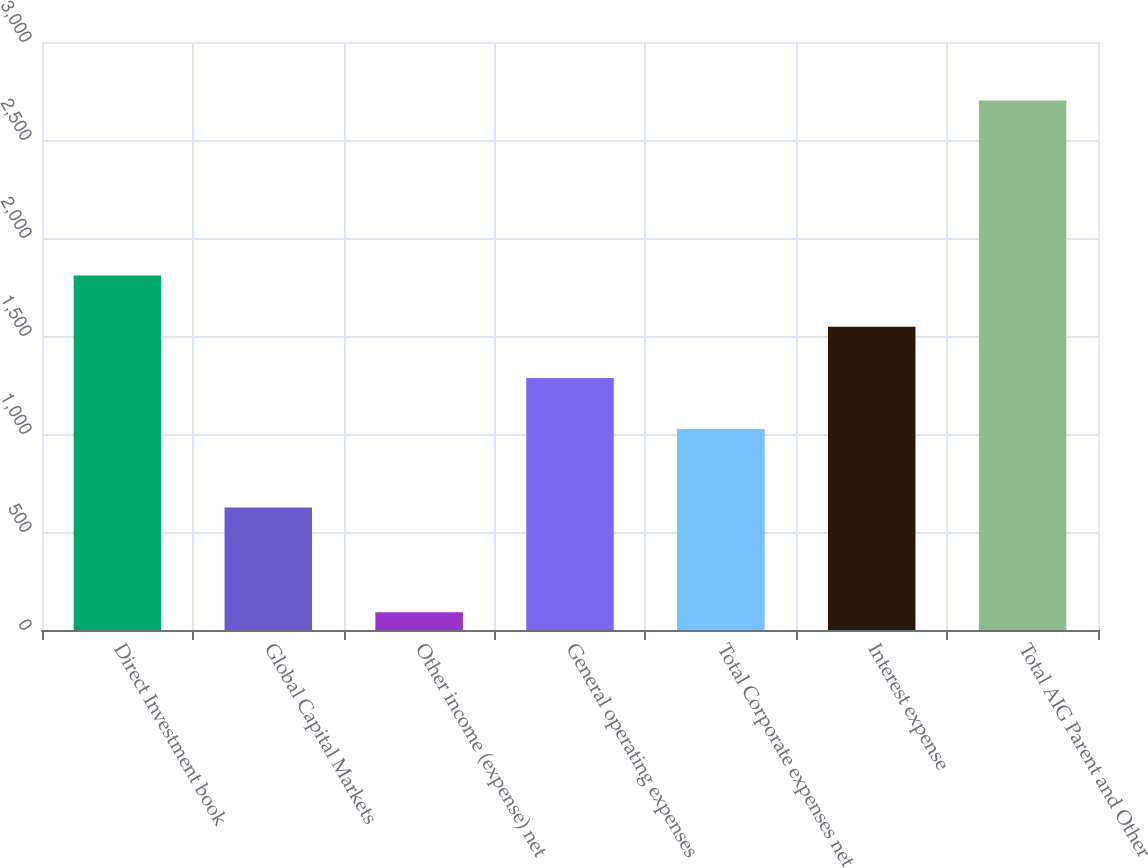Convert chart to OTSL. <chart><loc_0><loc_0><loc_500><loc_500><bar_chart><fcel>Direct Investment book<fcel>Global Capital Markets<fcel>Other income (expense) net<fcel>General operating expenses<fcel>Total Corporate expenses net<fcel>Interest expense<fcel>Total AIG Parent and Other<nl><fcel>1808.6<fcel>625<fcel>90<fcel>1286.2<fcel>1025<fcel>1547.4<fcel>2702<nl></chart> 